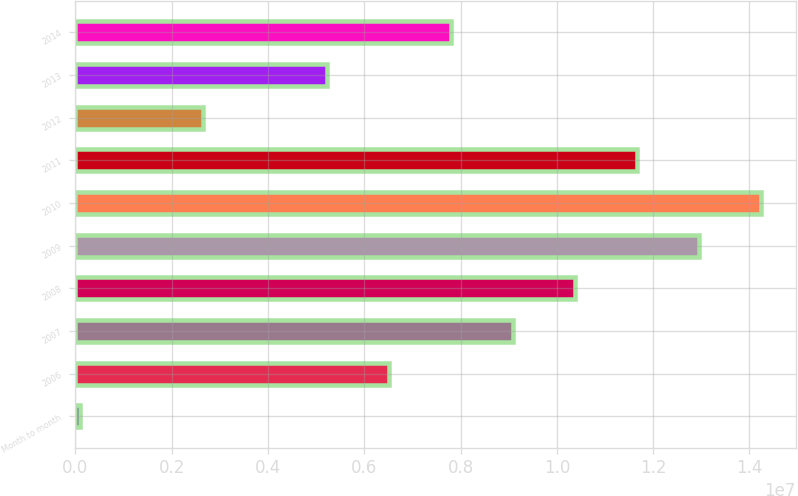<chart> <loc_0><loc_0><loc_500><loc_500><bar_chart><fcel>Month to month<fcel>2006<fcel>2007<fcel>2008<fcel>2009<fcel>2010<fcel>2011<fcel>2012<fcel>2013<fcel>2014<nl><fcel>86000<fcel>6.5112e+06<fcel>9.09e+06<fcel>1.03794e+07<fcel>1.29582e+07<fcel>1.42476e+07<fcel>1.16688e+07<fcel>2.643e+06<fcel>5.2218e+06<fcel>7.8006e+06<nl></chart> 